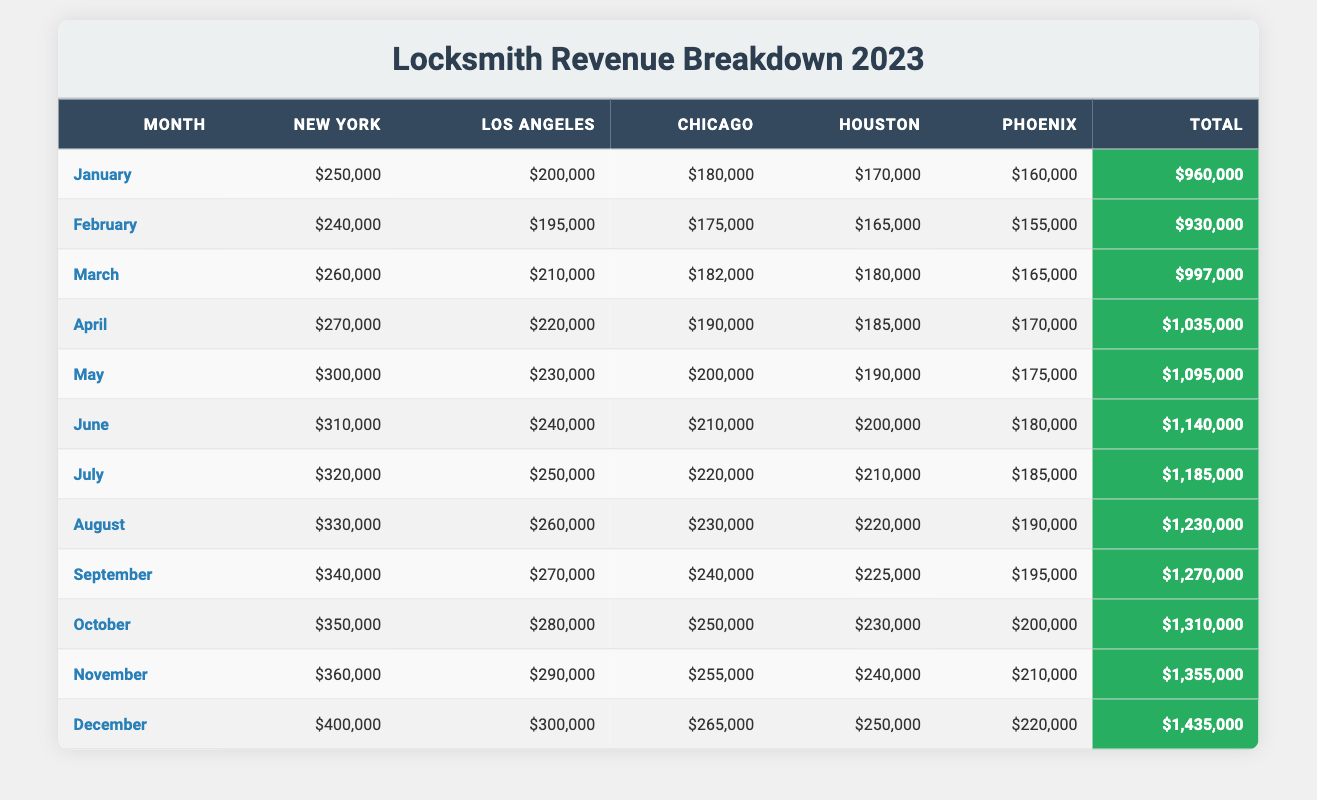What is the total revenue for New York in December? From the table, in December, New York's revenue is listed as $400,000.
Answer: $400,000 Which city made the least revenue in January? By comparing the revenue in January for each city: New York: $250,000, Los Angeles: $200,000, Chicago: $180,000, Houston: $170,000, and Phoenix: $160,000. The lowest value is Phoenix at $160,000.
Answer: Phoenix What is the average revenue for Los Angeles over the year? Sum the revenues for Los Angeles across all months: $200,000 + $195,000 + $210,000 + $220,000 + $230,000 + $240,000 + $250,000 + $260,000 + $270,000 + $280,000 + $290,000 + $300,000 = $2,925,000. There are 12 months, so the average is $2,925,000 / 12 = $243,750.
Answer: $243,750 Did Chicago earn more than Houston in July? Checking the table, Chicago's revenue in July is $220,000 while Houston's is $210,000. Chicago earned more than Houston.
Answer: Yes What is the total revenue for all cities in September? To find the total revenue in September, we sum the values from each city: New York: $340,000 + Los Angeles: $270,000 + Chicago: $240,000 + Houston: $225,000 + Phoenix: $195,000 = $1,260,000.
Answer: $1,260,000 During which month did Los Angeles show its highest revenue? Looking at the monthly data for Los Angeles: $200,000 in January, $195,000 in February, $210,000 in March, $220,000 in April, $230,000 in May, $240,000 in June, $250,000 in July, $260,000 in August, $270,000 in September, $280,000 in October, $290,000 in November, and $300,000 in December. The highest is in December at $300,000.
Answer: December What is the increase in revenue for New York from January to June? New York's revenue in January is $250,000 and in June is $310,000. The increase is $310,000 - $250,000 = $60,000.
Answer: $60,000 How much more did Houston earn than Phoenix in April? In April, Houston's revenue is $185,000 and Phoenix's is $170,000. The difference is $185,000 - $170,000 = $15,000.
Answer: $15,000 Which city had the highest revenue total for the year? To find the city with the highest total, we can sum revenues for all cities: New York: $3,688,000; Los Angeles: $3,345,000; Chicago: $2,996,000; Houston: $2,635,000; Phoenix: $2,262,000. New York has the highest total at $3,688,000.
Answer: New York 